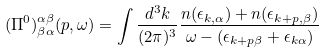Convert formula to latex. <formula><loc_0><loc_0><loc_500><loc_500>( \Pi ^ { 0 } ) ^ { \alpha \beta } _ { \beta \alpha } ( p , \omega ) = \int \frac { d ^ { 3 } k } { ( 2 \pi ) ^ { 3 } } \frac { n ( \epsilon _ { k , \alpha } ) + n ( \epsilon _ { k + p , \beta } ) } { \omega - ( \epsilon _ { k + p \beta } + \epsilon _ { k \alpha } ) }</formula> 